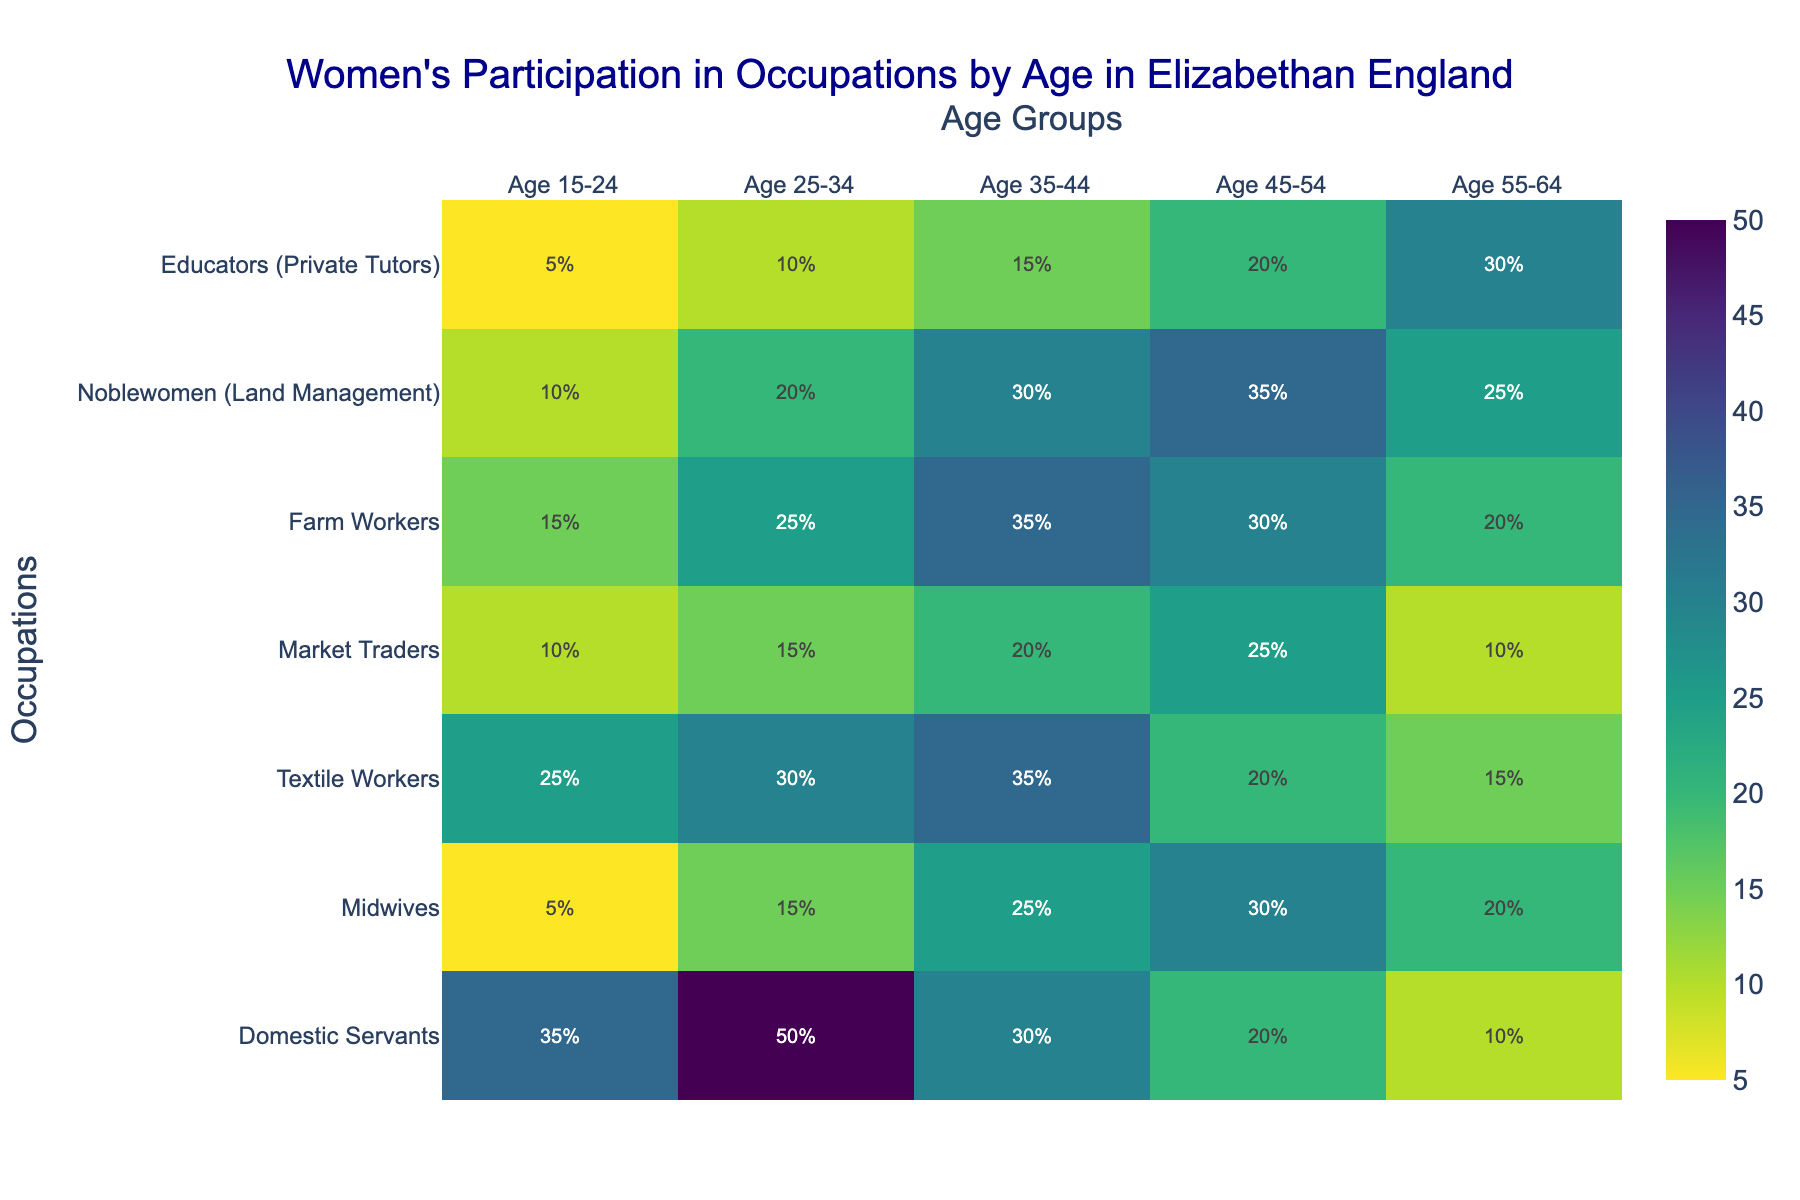What's the title of the heatmap? The title is directly visible at the top of the heatmap. It provides a contextual summary of the data presented.
Answer: "Women's Participation in Occupations by Age in Elizabethan England" On the heatmap, which age group has the highest participation for Domestic Servants? Looking at the Domestic Servants row, the cell with the highest value is under Age 25-34.
Answer: Age 25-34 How many occupations are depicted in the heatmap? To determine this, count the number of rows representing different occupations. There are seven rows.
Answer: 7 In which occupation does the participation level decrease contantly as age increases? Observing the trends across the row data per occupation, Domestic Servants shows a consistent decrease from Age 25-34 onwards.
Answer: Domestic Servants Which occupation shows an increasing trend in participation with age, peaking at Age 45-54? By examining the values in each occupation row, Noblewomen (Land Management) peaks at Age 45-54.
Answer: Noblewomen (Land Management) How does the participation for Midwives change across age groups? Review the data for Midwives: starting from Age 15-24 (5), it increases through Age 55-64 (20).
Answer: Increases overall Which two age groups have the highest participation in Textile Workers, and how do they compare? Analyze the values in the Textile Workers row. Age 35-44 (35) is the highest, followed by Age 25-34 (30). Therefore, Age 35-44 is greater by 5 percentile points.
Answer: Age 35-44 and Age 25-34; Age 35-44 is greater by 5 Considering Farm Workers and Noblewomen (Land Management), which has a higher participation above 30% and in which age groups? Compare participation percentages in Farm Workers and Noblewomen (Land Management) rows. Farm Workers have 35% in Age 35-44; Noblewomen (Land Management) have 35% in Age 45-54, 30% in Age 35-44, and 25% in Age 55-64.
Answer: Farm Workers (35% in Age 35-44), Noblewomen (30%+ in Age 35-44 and Age 45-54) Which occupation sees a peak in participation at the oldest age group (Age 55-64)? Review the percentage of 55-64 for each occupation, and Educators (Private Tutors) has the peak at 30%.
Answer: Educators (Private Tutors) What is the average participation of Textile Workers across all age groups? Add the percentages for Textile Workers: 25 + 30 + 35 + 20 + 15 = 125. Divide by the number of age groups (5).
Answer: 25% 